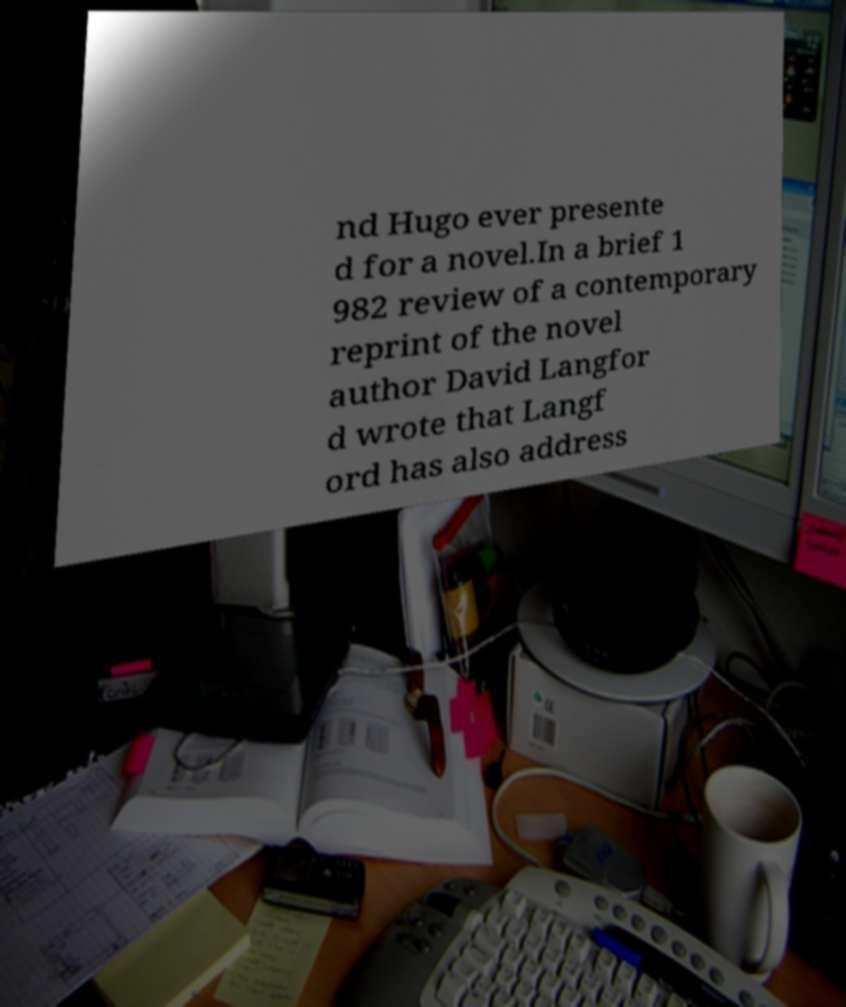What messages or text are displayed in this image? I need them in a readable, typed format. nd Hugo ever presente d for a novel.In a brief 1 982 review of a contemporary reprint of the novel author David Langfor d wrote that Langf ord has also address 